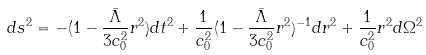<formula> <loc_0><loc_0><loc_500><loc_500>d s ^ { 2 } = - ( 1 - \frac { \bar { \Lambda } } { 3 c _ { 0 } ^ { 2 } } r ^ { 2 } ) d t ^ { 2 } + \frac { 1 } { c _ { 0 } ^ { 2 } } ( 1 - \frac { \bar { \Lambda } } { 3 c _ { 0 } ^ { 2 } } r ^ { 2 } ) ^ { - 1 } d r ^ { 2 } + \frac { 1 } { c _ { 0 } ^ { 2 } } r ^ { 2 } d \Omega ^ { 2 }</formula> 